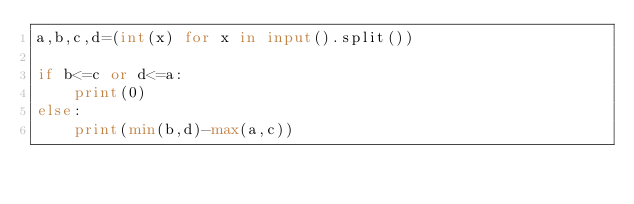Convert code to text. <code><loc_0><loc_0><loc_500><loc_500><_Python_>a,b,c,d=(int(x) for x in input().split())

if b<=c or d<=a:
    print(0)
else:
    print(min(b,d)-max(a,c))
</code> 